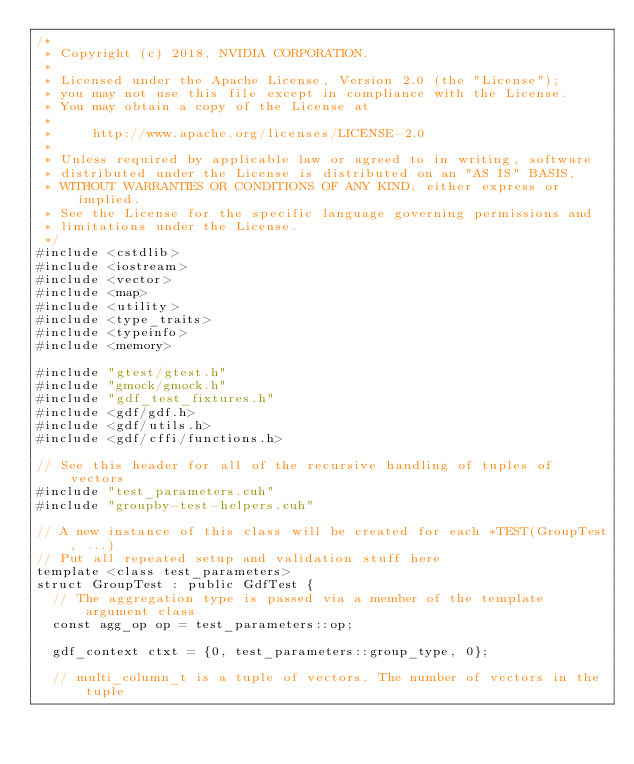Convert code to text. <code><loc_0><loc_0><loc_500><loc_500><_Cuda_>/*
 * Copyright (c) 2018, NVIDIA CORPORATION.
 *
 * Licensed under the Apache License, Version 2.0 (the "License");
 * you may not use this file except in compliance with the License.
 * You may obtain a copy of the License at
 *
 *     http://www.apache.org/licenses/LICENSE-2.0
 *
 * Unless required by applicable law or agreed to in writing, software
 * distributed under the License is distributed on an "AS IS" BASIS,
 * WITHOUT WARRANTIES OR CONDITIONS OF ANY KIND, either express or implied.
 * See the License for the specific language governing permissions and
 * limitations under the License.
 */
#include <cstdlib>
#include <iostream>
#include <vector>
#include <map>
#include <utility>
#include <type_traits>
#include <typeinfo>
#include <memory>

#include "gtest/gtest.h"
#include "gmock/gmock.h"
#include "gdf_test_fixtures.h"
#include <gdf/gdf.h>
#include <gdf/utils.h>
#include <gdf/cffi/functions.h>

// See this header for all of the recursive handling of tuples of vectors
#include "test_parameters.cuh"
#include "groupby-test-helpers.cuh"

// A new instance of this class will be created for each *TEST(GroupTest, ...)
// Put all repeated setup and validation stuff here
template <class test_parameters>
struct GroupTest : public GdfTest {
  // The aggregation type is passed via a member of the template argument class
  const agg_op op = test_parameters::op;

  gdf_context ctxt = {0, test_parameters::group_type, 0};

  // multi_column_t is a tuple of vectors. The number of vectors in the tuple</code> 